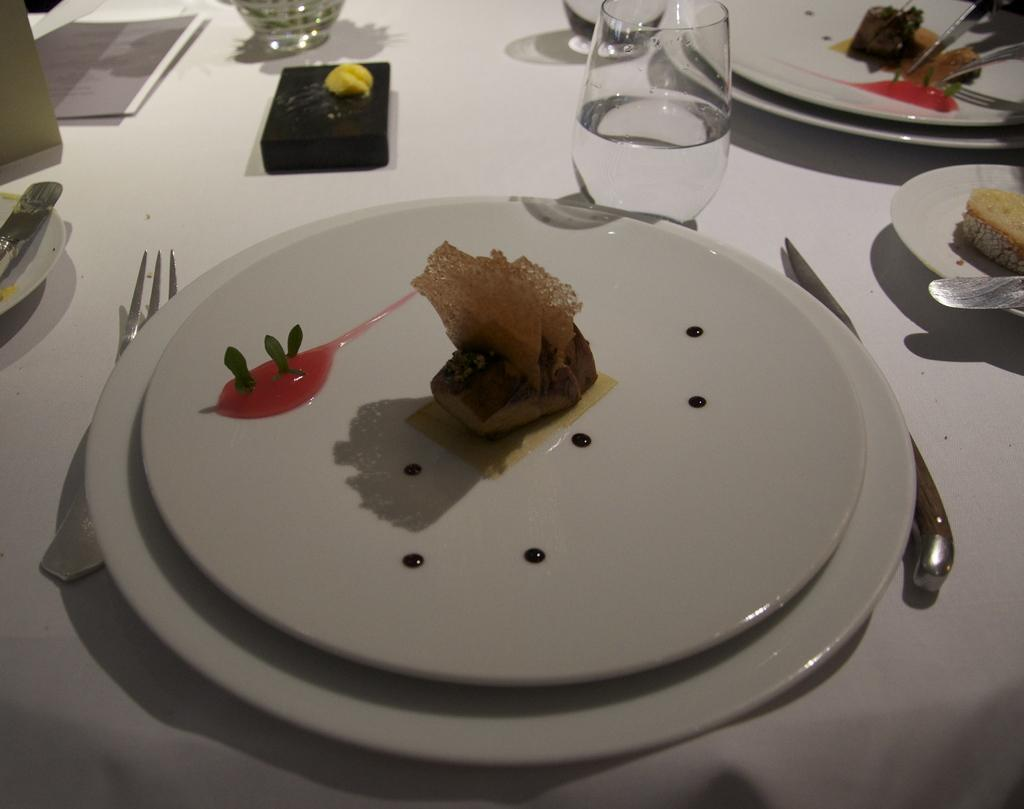What piece of furniture is present in the image? There is a table in the image. What objects are placed on the table? There are plates, glasses, a fork, and spoons on the table. How many types of utensils can be seen on the table? There are two types of utensils on the table: a fork and spoons. What type of robin can be seen in the image? There is no robin present in the image; it features a table with various objects on it. What material is the zoo made of in the image? There is no zoo present in the image; it features a table with various objects on it. 